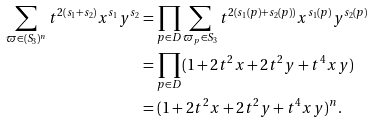<formula> <loc_0><loc_0><loc_500><loc_500>\sum _ { \varpi \in ( S _ { 3 } ) ^ { n } } t ^ { 2 ( s _ { 1 } + s _ { 2 } ) } x ^ { s _ { 1 } } y ^ { s _ { 2 } } & = \prod _ { p \in D } \sum _ { \varpi _ { p } \in S _ { 3 } } t ^ { 2 ( s _ { 1 } ( p ) + s _ { 2 } ( p ) ) } x ^ { s _ { 1 } ( p ) } y ^ { s _ { 2 } ( p ) } \\ & = \prod _ { p \in D } ( 1 + 2 t ^ { 2 } x + 2 t ^ { 2 } y + t ^ { 4 } x y ) \\ & = ( 1 + 2 t ^ { 2 } x + 2 t ^ { 2 } y + t ^ { 4 } x y ) ^ { n } .</formula> 